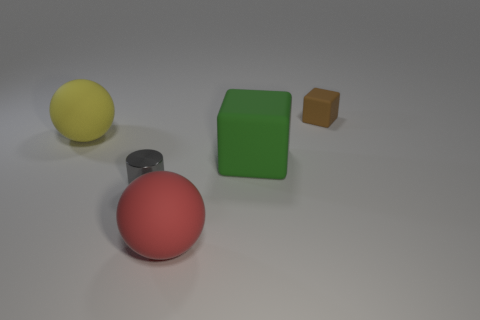Add 3 gray things. How many objects exist? 8 Subtract all cylinders. How many objects are left? 4 Subtract all big red rubber things. Subtract all gray metal cylinders. How many objects are left? 3 Add 4 green cubes. How many green cubes are left? 5 Add 1 large red shiny spheres. How many large red shiny spheres exist? 1 Subtract 1 gray cylinders. How many objects are left? 4 